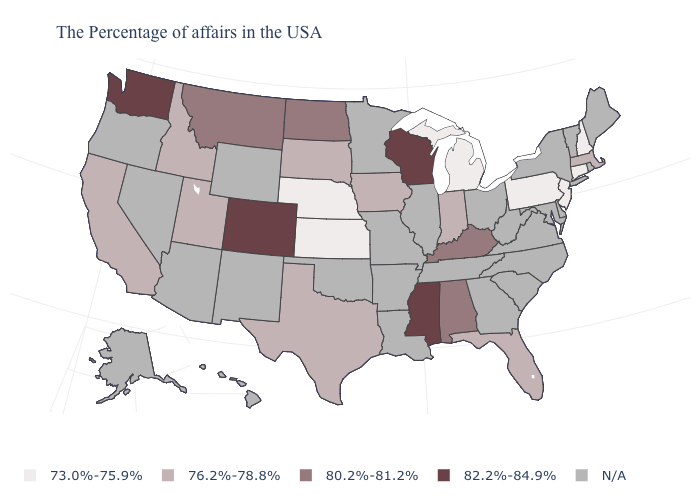What is the value of Alaska?
Give a very brief answer. N/A. What is the value of Oregon?
Answer briefly. N/A. What is the value of Colorado?
Be succinct. 82.2%-84.9%. Does New Hampshire have the lowest value in the USA?
Keep it brief. Yes. What is the value of Alabama?
Write a very short answer. 80.2%-81.2%. What is the value of North Dakota?
Be succinct. 80.2%-81.2%. How many symbols are there in the legend?
Answer briefly. 5. What is the value of Iowa?
Give a very brief answer. 76.2%-78.8%. What is the lowest value in the Northeast?
Give a very brief answer. 73.0%-75.9%. What is the highest value in states that border Virginia?
Answer briefly. 80.2%-81.2%. What is the value of Kansas?
Short answer required. 73.0%-75.9%. Does the map have missing data?
Give a very brief answer. Yes. 